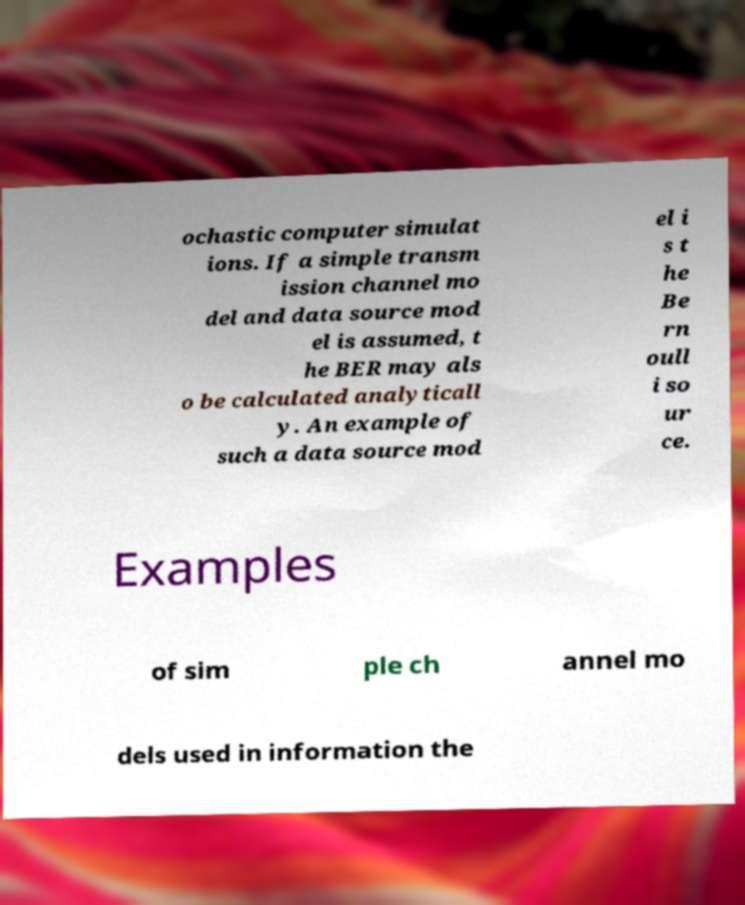For documentation purposes, I need the text within this image transcribed. Could you provide that? ochastic computer simulat ions. If a simple transm ission channel mo del and data source mod el is assumed, t he BER may als o be calculated analyticall y. An example of such a data source mod el i s t he Be rn oull i so ur ce. Examples of sim ple ch annel mo dels used in information the 